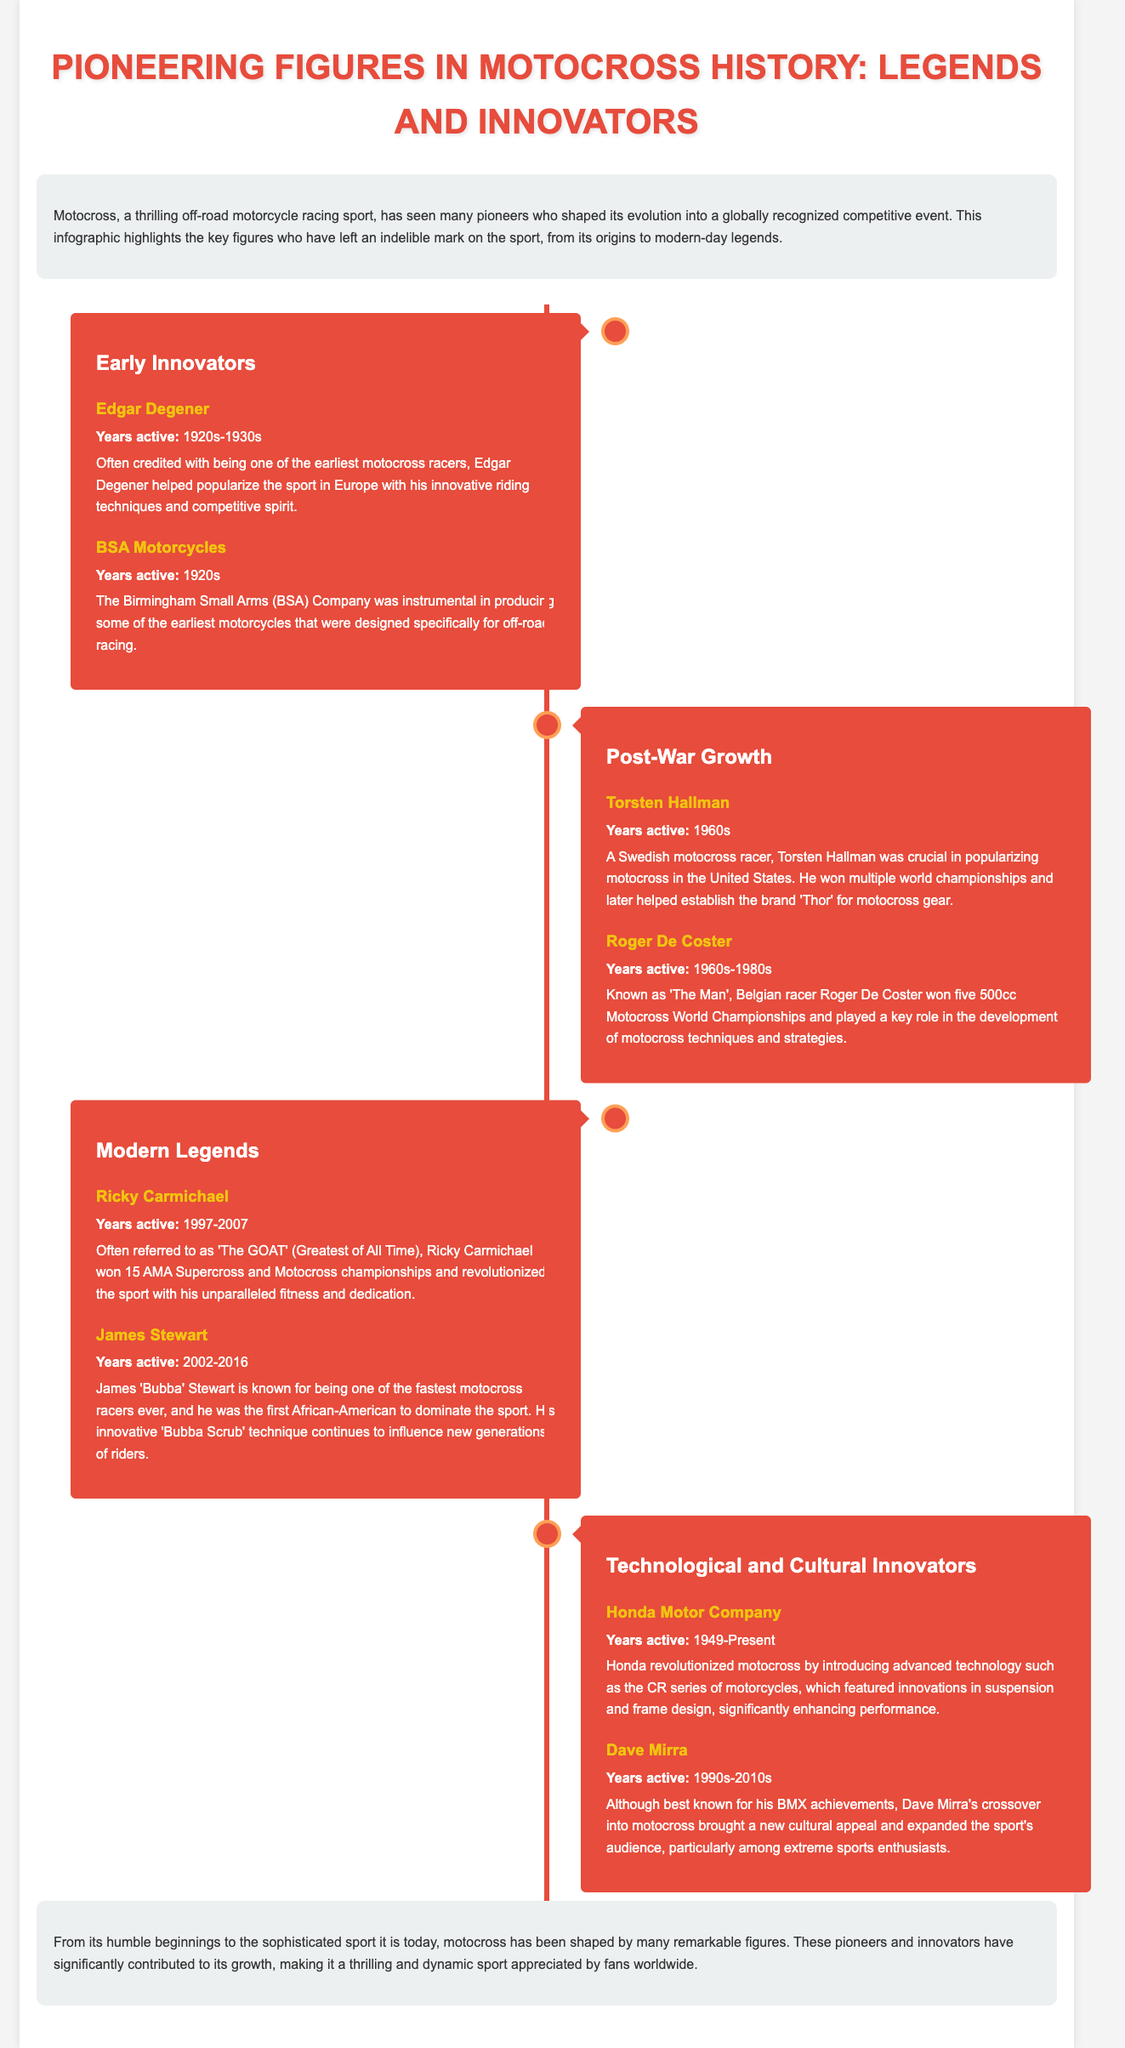What years was Edgar Degener active? Edgar Degener was active during the 1920s to 1930s.
Answer: 1920s-1930s Which company was instrumental in producing early off-road motorcycles? The Birmingham Small Arms (BSA) Company was crucial in this regard.
Answer: BSA Motorcycles Who is known as 'The Man' in motocross history? Roger De Coster is referred to as 'The Man.'
Answer: Roger De Coster What is Ricky Carmichael often referred to as? Ricky Carmichael is often called 'The GOAT' (Greatest of All Time).
Answer: The GOAT Which technique is James Stewart known for innovating? James Stewart is known for the 'Bubba Scrub' technique.
Answer: Bubba Scrub What year did Honda Motor Company begin its impact on motocross? Honda started its impact in 1949.
Answer: 1949 How many world championships did Roger De Coster win? Roger De Coster won five 500cc Motocross World Championships.
Answer: five What decade was Torsten Hallman a key figure in motocross? Torsten Hallman was active in the 1960s.
Answer: 1960s What cultural impact did Dave Mirra have on motocross? Dave Mirra expanded the sport's audience among extreme sports enthusiasts.
Answer: Expanded audience 